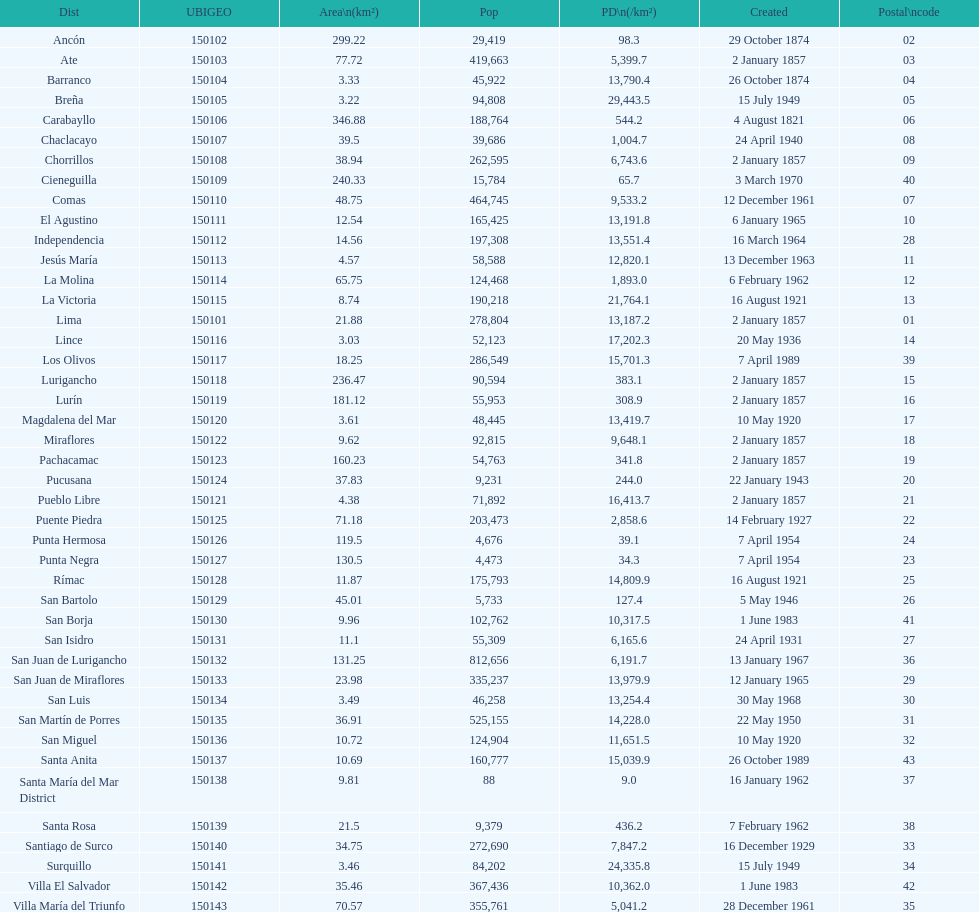In how many districts is the population density at least 100 31. 